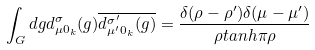<formula> <loc_0><loc_0><loc_500><loc_500>\int _ { G } d g d _ { \mu 0 _ { k } } ^ { \sigma } ( g ) \overline { d _ { \mu ^ { \prime } 0 _ { k } } ^ { \sigma ^ { \prime } } ( g ) } = \frac { \delta ( \rho - \rho ^ { \prime } ) \delta ( \mu - \mu ^ { \prime } ) } { \rho t a n h \pi \rho }</formula> 